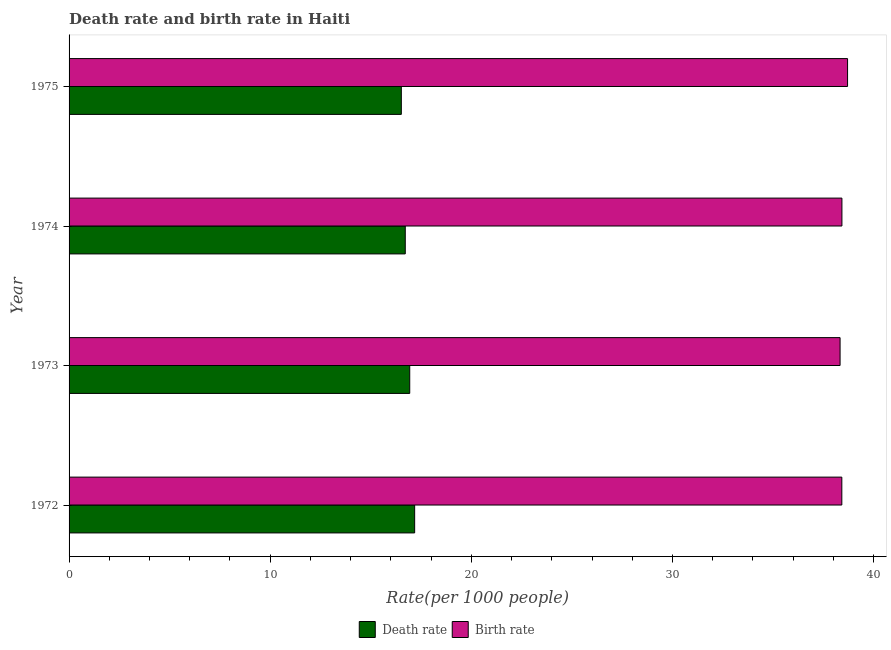How many different coloured bars are there?
Keep it short and to the point. 2. Are the number of bars per tick equal to the number of legend labels?
Offer a terse response. Yes. Are the number of bars on each tick of the Y-axis equal?
Ensure brevity in your answer.  Yes. What is the birth rate in 1974?
Offer a terse response. 38.42. Across all years, what is the maximum death rate?
Your answer should be very brief. 17.18. Across all years, what is the minimum death rate?
Offer a very short reply. 16.52. In which year was the birth rate maximum?
Provide a succinct answer. 1975. What is the total birth rate in the graph?
Your response must be concise. 153.88. What is the difference between the birth rate in 1972 and that in 1973?
Your answer should be compact. 0.09. What is the difference between the birth rate in 1975 and the death rate in 1973?
Make the answer very short. 21.77. What is the average death rate per year?
Your answer should be compact. 16.84. In the year 1975, what is the difference between the birth rate and death rate?
Provide a short and direct response. 22.19. What is the ratio of the birth rate in 1972 to that in 1973?
Ensure brevity in your answer.  1. Is the birth rate in 1973 less than that in 1974?
Provide a succinct answer. Yes. What is the difference between the highest and the second highest death rate?
Provide a short and direct response. 0.24. What is the difference between the highest and the lowest death rate?
Offer a very short reply. 0.66. What does the 1st bar from the top in 1975 represents?
Offer a very short reply. Birth rate. What does the 1st bar from the bottom in 1973 represents?
Your answer should be compact. Death rate. How many bars are there?
Keep it short and to the point. 8. Are the values on the major ticks of X-axis written in scientific E-notation?
Your answer should be compact. No. Does the graph contain any zero values?
Your response must be concise. No. What is the title of the graph?
Provide a succinct answer. Death rate and birth rate in Haiti. Does "Diarrhea" appear as one of the legend labels in the graph?
Provide a succinct answer. No. What is the label or title of the X-axis?
Make the answer very short. Rate(per 1000 people). What is the label or title of the Y-axis?
Your answer should be very brief. Year. What is the Rate(per 1000 people) in Death rate in 1972?
Your answer should be compact. 17.18. What is the Rate(per 1000 people) in Birth rate in 1972?
Make the answer very short. 38.42. What is the Rate(per 1000 people) of Death rate in 1973?
Your response must be concise. 16.94. What is the Rate(per 1000 people) of Birth rate in 1973?
Offer a very short reply. 38.33. What is the Rate(per 1000 people) of Death rate in 1974?
Your answer should be very brief. 16.71. What is the Rate(per 1000 people) in Birth rate in 1974?
Offer a terse response. 38.42. What is the Rate(per 1000 people) of Death rate in 1975?
Make the answer very short. 16.52. What is the Rate(per 1000 people) in Birth rate in 1975?
Give a very brief answer. 38.7. Across all years, what is the maximum Rate(per 1000 people) of Death rate?
Ensure brevity in your answer.  17.18. Across all years, what is the maximum Rate(per 1000 people) of Birth rate?
Your answer should be very brief. 38.7. Across all years, what is the minimum Rate(per 1000 people) of Death rate?
Keep it short and to the point. 16.52. Across all years, what is the minimum Rate(per 1000 people) of Birth rate?
Make the answer very short. 38.33. What is the total Rate(per 1000 people) of Death rate in the graph?
Keep it short and to the point. 67.35. What is the total Rate(per 1000 people) in Birth rate in the graph?
Offer a very short reply. 153.88. What is the difference between the Rate(per 1000 people) in Death rate in 1972 and that in 1973?
Ensure brevity in your answer.  0.24. What is the difference between the Rate(per 1000 people) of Birth rate in 1972 and that in 1973?
Ensure brevity in your answer.  0.09. What is the difference between the Rate(per 1000 people) of Death rate in 1972 and that in 1974?
Your answer should be compact. 0.47. What is the difference between the Rate(per 1000 people) of Birth rate in 1972 and that in 1974?
Make the answer very short. -0. What is the difference between the Rate(per 1000 people) in Death rate in 1972 and that in 1975?
Your answer should be very brief. 0.66. What is the difference between the Rate(per 1000 people) in Birth rate in 1972 and that in 1975?
Offer a terse response. -0.28. What is the difference between the Rate(per 1000 people) of Death rate in 1973 and that in 1974?
Ensure brevity in your answer.  0.22. What is the difference between the Rate(per 1000 people) in Birth rate in 1973 and that in 1974?
Provide a short and direct response. -0.09. What is the difference between the Rate(per 1000 people) in Death rate in 1973 and that in 1975?
Your response must be concise. 0.42. What is the difference between the Rate(per 1000 people) of Birth rate in 1973 and that in 1975?
Provide a succinct answer. -0.37. What is the difference between the Rate(per 1000 people) in Death rate in 1974 and that in 1975?
Provide a short and direct response. 0.2. What is the difference between the Rate(per 1000 people) in Birth rate in 1974 and that in 1975?
Provide a short and direct response. -0.28. What is the difference between the Rate(per 1000 people) of Death rate in 1972 and the Rate(per 1000 people) of Birth rate in 1973?
Offer a terse response. -21.15. What is the difference between the Rate(per 1000 people) of Death rate in 1972 and the Rate(per 1000 people) of Birth rate in 1974?
Your answer should be very brief. -21.24. What is the difference between the Rate(per 1000 people) of Death rate in 1972 and the Rate(per 1000 people) of Birth rate in 1975?
Offer a terse response. -21.52. What is the difference between the Rate(per 1000 people) in Death rate in 1973 and the Rate(per 1000 people) in Birth rate in 1974?
Your answer should be compact. -21.49. What is the difference between the Rate(per 1000 people) in Death rate in 1973 and the Rate(per 1000 people) in Birth rate in 1975?
Provide a short and direct response. -21.77. What is the difference between the Rate(per 1000 people) in Death rate in 1974 and the Rate(per 1000 people) in Birth rate in 1975?
Offer a very short reply. -21.99. What is the average Rate(per 1000 people) of Death rate per year?
Your answer should be compact. 16.84. What is the average Rate(per 1000 people) in Birth rate per year?
Ensure brevity in your answer.  38.47. In the year 1972, what is the difference between the Rate(per 1000 people) in Death rate and Rate(per 1000 people) in Birth rate?
Offer a terse response. -21.24. In the year 1973, what is the difference between the Rate(per 1000 people) of Death rate and Rate(per 1000 people) of Birth rate?
Ensure brevity in your answer.  -21.4. In the year 1974, what is the difference between the Rate(per 1000 people) of Death rate and Rate(per 1000 people) of Birth rate?
Give a very brief answer. -21.71. In the year 1975, what is the difference between the Rate(per 1000 people) in Death rate and Rate(per 1000 people) in Birth rate?
Your answer should be compact. -22.19. What is the ratio of the Rate(per 1000 people) in Death rate in 1972 to that in 1973?
Your answer should be compact. 1.01. What is the ratio of the Rate(per 1000 people) of Birth rate in 1972 to that in 1973?
Make the answer very short. 1. What is the ratio of the Rate(per 1000 people) of Death rate in 1972 to that in 1974?
Your answer should be compact. 1.03. What is the ratio of the Rate(per 1000 people) in Death rate in 1972 to that in 1975?
Your response must be concise. 1.04. What is the ratio of the Rate(per 1000 people) of Birth rate in 1972 to that in 1975?
Your answer should be compact. 0.99. What is the ratio of the Rate(per 1000 people) in Death rate in 1973 to that in 1974?
Offer a very short reply. 1.01. What is the ratio of the Rate(per 1000 people) of Birth rate in 1973 to that in 1974?
Your response must be concise. 1. What is the ratio of the Rate(per 1000 people) of Death rate in 1973 to that in 1975?
Your response must be concise. 1.03. What is the ratio of the Rate(per 1000 people) in Birth rate in 1973 to that in 1975?
Your answer should be compact. 0.99. What is the ratio of the Rate(per 1000 people) of Death rate in 1974 to that in 1975?
Your answer should be very brief. 1.01. What is the ratio of the Rate(per 1000 people) of Birth rate in 1974 to that in 1975?
Your response must be concise. 0.99. What is the difference between the highest and the second highest Rate(per 1000 people) of Death rate?
Offer a terse response. 0.24. What is the difference between the highest and the second highest Rate(per 1000 people) in Birth rate?
Ensure brevity in your answer.  0.28. What is the difference between the highest and the lowest Rate(per 1000 people) in Death rate?
Your answer should be compact. 0.66. What is the difference between the highest and the lowest Rate(per 1000 people) in Birth rate?
Your response must be concise. 0.37. 